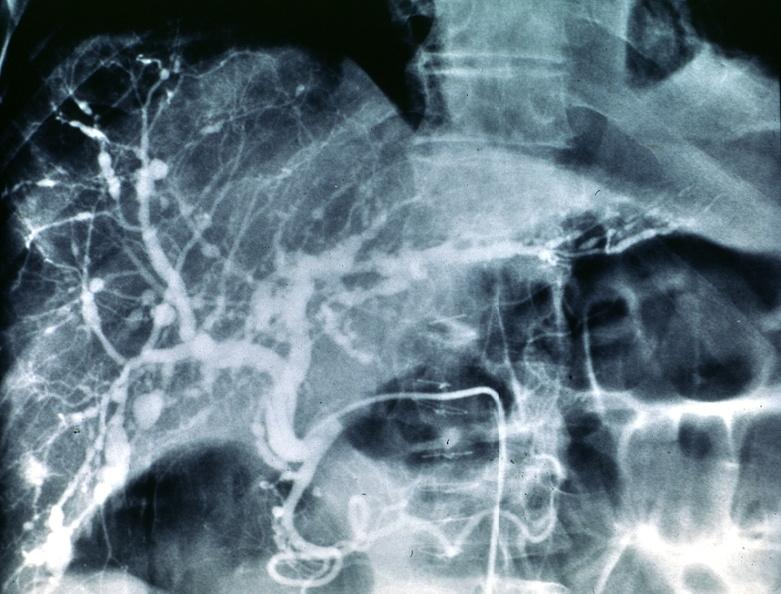does this image show polyarteritis nodosa, liver arteriogram?
Answer the question using a single word or phrase. Yes 